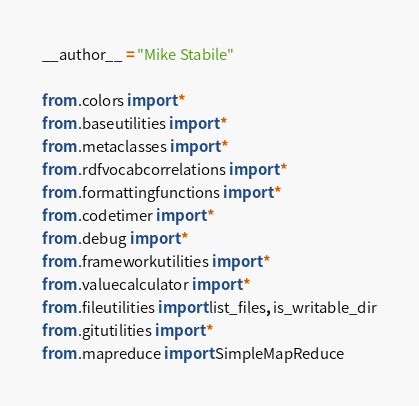<code> <loc_0><loc_0><loc_500><loc_500><_Python_>__author__ = "Mike Stabile"

from .colors import *
from .baseutilities import *
from .metaclasses import *
from .rdfvocabcorrelations import *
from .formattingfunctions import *
from .codetimer import *
from .debug import *
from .frameworkutilities import *
from .valuecalculator import *
from .fileutilities import list_files, is_writable_dir
from .gitutilities import *
from .mapreduce import SimpleMapReduce
</code> 